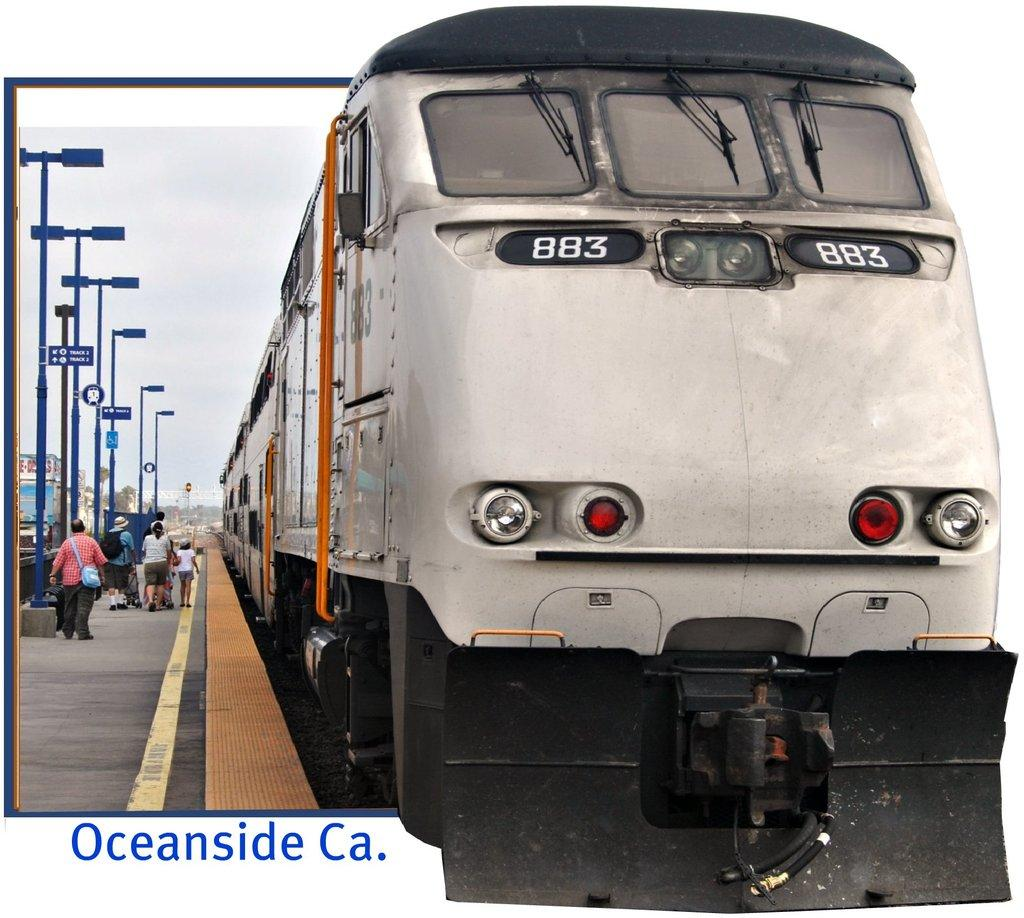<image>
Relay a brief, clear account of the picture shown. Train number 883 is stopped in Oceanside Ca 